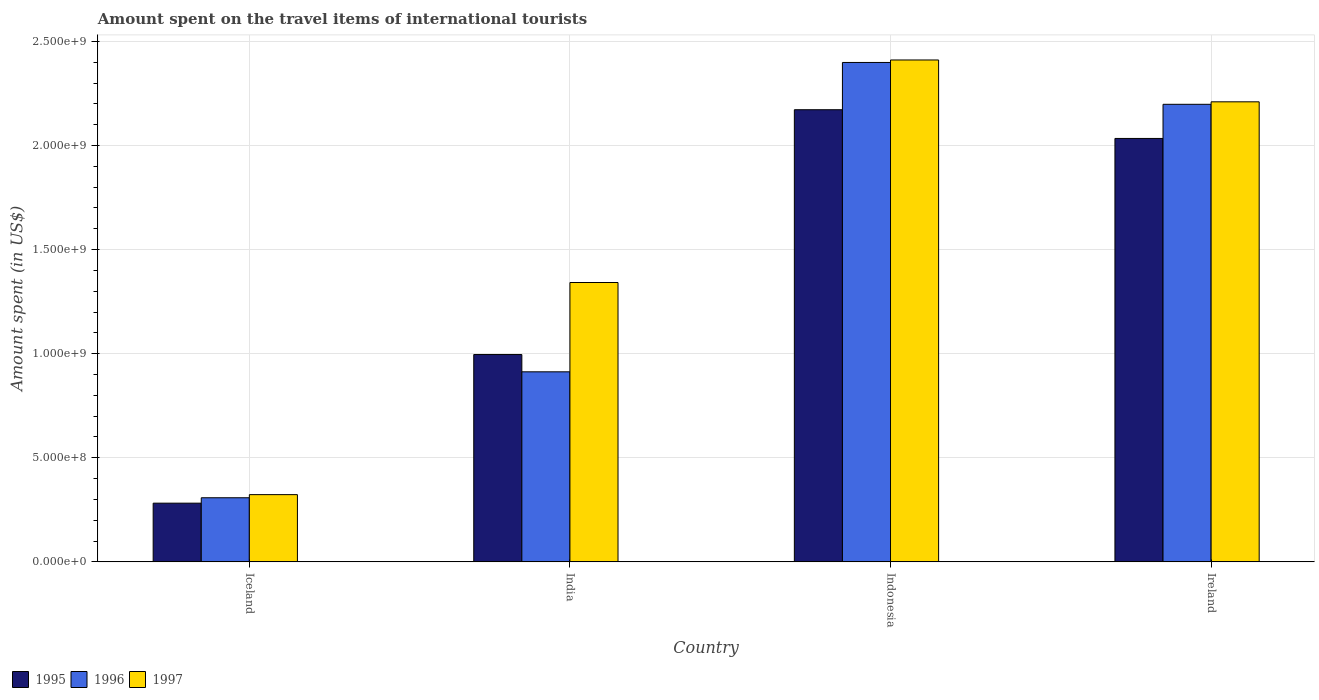How many different coloured bars are there?
Give a very brief answer. 3. How many groups of bars are there?
Your answer should be compact. 4. Are the number of bars per tick equal to the number of legend labels?
Make the answer very short. Yes. Are the number of bars on each tick of the X-axis equal?
Your answer should be compact. Yes. How many bars are there on the 1st tick from the right?
Keep it short and to the point. 3. What is the label of the 1st group of bars from the left?
Provide a succinct answer. Iceland. In how many cases, is the number of bars for a given country not equal to the number of legend labels?
Provide a succinct answer. 0. What is the amount spent on the travel items of international tourists in 1997 in Ireland?
Make the answer very short. 2.21e+09. Across all countries, what is the maximum amount spent on the travel items of international tourists in 1997?
Ensure brevity in your answer.  2.41e+09. Across all countries, what is the minimum amount spent on the travel items of international tourists in 1995?
Offer a very short reply. 2.82e+08. In which country was the amount spent on the travel items of international tourists in 1996 maximum?
Ensure brevity in your answer.  Indonesia. What is the total amount spent on the travel items of international tourists in 1997 in the graph?
Your answer should be compact. 6.29e+09. What is the difference between the amount spent on the travel items of international tourists in 1995 in Iceland and that in Indonesia?
Give a very brief answer. -1.89e+09. What is the difference between the amount spent on the travel items of international tourists in 1997 in India and the amount spent on the travel items of international tourists in 1996 in Ireland?
Your answer should be compact. -8.56e+08. What is the average amount spent on the travel items of international tourists in 1995 per country?
Your response must be concise. 1.37e+09. What is the difference between the amount spent on the travel items of international tourists of/in 1995 and amount spent on the travel items of international tourists of/in 1997 in Ireland?
Your answer should be compact. -1.76e+08. In how many countries, is the amount spent on the travel items of international tourists in 1997 greater than 1600000000 US$?
Provide a succinct answer. 2. What is the ratio of the amount spent on the travel items of international tourists in 1996 in Iceland to that in Indonesia?
Your answer should be very brief. 0.13. What is the difference between the highest and the second highest amount spent on the travel items of international tourists in 1995?
Your answer should be very brief. 1.18e+09. What is the difference between the highest and the lowest amount spent on the travel items of international tourists in 1997?
Offer a very short reply. 2.09e+09. In how many countries, is the amount spent on the travel items of international tourists in 1995 greater than the average amount spent on the travel items of international tourists in 1995 taken over all countries?
Ensure brevity in your answer.  2. What does the 1st bar from the left in India represents?
Your answer should be very brief. 1995. What does the 1st bar from the right in Iceland represents?
Your response must be concise. 1997. Is it the case that in every country, the sum of the amount spent on the travel items of international tourists in 1996 and amount spent on the travel items of international tourists in 1997 is greater than the amount spent on the travel items of international tourists in 1995?
Your response must be concise. Yes. How many countries are there in the graph?
Your answer should be compact. 4. Are the values on the major ticks of Y-axis written in scientific E-notation?
Your response must be concise. Yes. Where does the legend appear in the graph?
Keep it short and to the point. Bottom left. How many legend labels are there?
Give a very brief answer. 3. How are the legend labels stacked?
Provide a succinct answer. Horizontal. What is the title of the graph?
Offer a very short reply. Amount spent on the travel items of international tourists. What is the label or title of the X-axis?
Offer a terse response. Country. What is the label or title of the Y-axis?
Offer a terse response. Amount spent (in US$). What is the Amount spent (in US$) of 1995 in Iceland?
Give a very brief answer. 2.82e+08. What is the Amount spent (in US$) in 1996 in Iceland?
Ensure brevity in your answer.  3.08e+08. What is the Amount spent (in US$) of 1997 in Iceland?
Your answer should be compact. 3.23e+08. What is the Amount spent (in US$) of 1995 in India?
Provide a succinct answer. 9.96e+08. What is the Amount spent (in US$) in 1996 in India?
Give a very brief answer. 9.13e+08. What is the Amount spent (in US$) in 1997 in India?
Give a very brief answer. 1.34e+09. What is the Amount spent (in US$) of 1995 in Indonesia?
Provide a succinct answer. 2.17e+09. What is the Amount spent (in US$) in 1996 in Indonesia?
Keep it short and to the point. 2.40e+09. What is the Amount spent (in US$) in 1997 in Indonesia?
Provide a succinct answer. 2.41e+09. What is the Amount spent (in US$) in 1995 in Ireland?
Your answer should be compact. 2.03e+09. What is the Amount spent (in US$) of 1996 in Ireland?
Your answer should be very brief. 2.20e+09. What is the Amount spent (in US$) of 1997 in Ireland?
Your response must be concise. 2.21e+09. Across all countries, what is the maximum Amount spent (in US$) in 1995?
Ensure brevity in your answer.  2.17e+09. Across all countries, what is the maximum Amount spent (in US$) in 1996?
Offer a terse response. 2.40e+09. Across all countries, what is the maximum Amount spent (in US$) of 1997?
Offer a very short reply. 2.41e+09. Across all countries, what is the minimum Amount spent (in US$) in 1995?
Offer a very short reply. 2.82e+08. Across all countries, what is the minimum Amount spent (in US$) of 1996?
Your answer should be very brief. 3.08e+08. Across all countries, what is the minimum Amount spent (in US$) in 1997?
Give a very brief answer. 3.23e+08. What is the total Amount spent (in US$) of 1995 in the graph?
Make the answer very short. 5.48e+09. What is the total Amount spent (in US$) in 1996 in the graph?
Your answer should be compact. 5.82e+09. What is the total Amount spent (in US$) in 1997 in the graph?
Offer a very short reply. 6.29e+09. What is the difference between the Amount spent (in US$) of 1995 in Iceland and that in India?
Your answer should be compact. -7.14e+08. What is the difference between the Amount spent (in US$) in 1996 in Iceland and that in India?
Offer a very short reply. -6.05e+08. What is the difference between the Amount spent (in US$) in 1997 in Iceland and that in India?
Offer a very short reply. -1.02e+09. What is the difference between the Amount spent (in US$) of 1995 in Iceland and that in Indonesia?
Your answer should be compact. -1.89e+09. What is the difference between the Amount spent (in US$) in 1996 in Iceland and that in Indonesia?
Offer a very short reply. -2.09e+09. What is the difference between the Amount spent (in US$) of 1997 in Iceland and that in Indonesia?
Make the answer very short. -2.09e+09. What is the difference between the Amount spent (in US$) in 1995 in Iceland and that in Ireland?
Provide a short and direct response. -1.75e+09. What is the difference between the Amount spent (in US$) in 1996 in Iceland and that in Ireland?
Your response must be concise. -1.89e+09. What is the difference between the Amount spent (in US$) of 1997 in Iceland and that in Ireland?
Your answer should be compact. -1.89e+09. What is the difference between the Amount spent (in US$) of 1995 in India and that in Indonesia?
Give a very brief answer. -1.18e+09. What is the difference between the Amount spent (in US$) of 1996 in India and that in Indonesia?
Your answer should be compact. -1.49e+09. What is the difference between the Amount spent (in US$) of 1997 in India and that in Indonesia?
Provide a succinct answer. -1.07e+09. What is the difference between the Amount spent (in US$) in 1995 in India and that in Ireland?
Your response must be concise. -1.04e+09. What is the difference between the Amount spent (in US$) in 1996 in India and that in Ireland?
Provide a succinct answer. -1.28e+09. What is the difference between the Amount spent (in US$) of 1997 in India and that in Ireland?
Provide a short and direct response. -8.68e+08. What is the difference between the Amount spent (in US$) in 1995 in Indonesia and that in Ireland?
Your response must be concise. 1.38e+08. What is the difference between the Amount spent (in US$) of 1996 in Indonesia and that in Ireland?
Provide a short and direct response. 2.01e+08. What is the difference between the Amount spent (in US$) in 1997 in Indonesia and that in Ireland?
Give a very brief answer. 2.01e+08. What is the difference between the Amount spent (in US$) in 1995 in Iceland and the Amount spent (in US$) in 1996 in India?
Provide a short and direct response. -6.31e+08. What is the difference between the Amount spent (in US$) of 1995 in Iceland and the Amount spent (in US$) of 1997 in India?
Provide a succinct answer. -1.06e+09. What is the difference between the Amount spent (in US$) in 1996 in Iceland and the Amount spent (in US$) in 1997 in India?
Your answer should be very brief. -1.03e+09. What is the difference between the Amount spent (in US$) in 1995 in Iceland and the Amount spent (in US$) in 1996 in Indonesia?
Your answer should be very brief. -2.12e+09. What is the difference between the Amount spent (in US$) in 1995 in Iceland and the Amount spent (in US$) in 1997 in Indonesia?
Offer a terse response. -2.13e+09. What is the difference between the Amount spent (in US$) in 1996 in Iceland and the Amount spent (in US$) in 1997 in Indonesia?
Ensure brevity in your answer.  -2.10e+09. What is the difference between the Amount spent (in US$) of 1995 in Iceland and the Amount spent (in US$) of 1996 in Ireland?
Offer a terse response. -1.92e+09. What is the difference between the Amount spent (in US$) of 1995 in Iceland and the Amount spent (in US$) of 1997 in Ireland?
Your response must be concise. -1.93e+09. What is the difference between the Amount spent (in US$) in 1996 in Iceland and the Amount spent (in US$) in 1997 in Ireland?
Offer a terse response. -1.90e+09. What is the difference between the Amount spent (in US$) of 1995 in India and the Amount spent (in US$) of 1996 in Indonesia?
Your answer should be compact. -1.40e+09. What is the difference between the Amount spent (in US$) in 1995 in India and the Amount spent (in US$) in 1997 in Indonesia?
Ensure brevity in your answer.  -1.42e+09. What is the difference between the Amount spent (in US$) of 1996 in India and the Amount spent (in US$) of 1997 in Indonesia?
Provide a succinct answer. -1.50e+09. What is the difference between the Amount spent (in US$) of 1995 in India and the Amount spent (in US$) of 1996 in Ireland?
Keep it short and to the point. -1.20e+09. What is the difference between the Amount spent (in US$) of 1995 in India and the Amount spent (in US$) of 1997 in Ireland?
Provide a succinct answer. -1.21e+09. What is the difference between the Amount spent (in US$) of 1996 in India and the Amount spent (in US$) of 1997 in Ireland?
Provide a short and direct response. -1.30e+09. What is the difference between the Amount spent (in US$) of 1995 in Indonesia and the Amount spent (in US$) of 1996 in Ireland?
Give a very brief answer. -2.60e+07. What is the difference between the Amount spent (in US$) in 1995 in Indonesia and the Amount spent (in US$) in 1997 in Ireland?
Offer a terse response. -3.80e+07. What is the difference between the Amount spent (in US$) of 1996 in Indonesia and the Amount spent (in US$) of 1997 in Ireland?
Your answer should be compact. 1.89e+08. What is the average Amount spent (in US$) of 1995 per country?
Your answer should be compact. 1.37e+09. What is the average Amount spent (in US$) of 1996 per country?
Provide a short and direct response. 1.45e+09. What is the average Amount spent (in US$) of 1997 per country?
Your answer should be very brief. 1.57e+09. What is the difference between the Amount spent (in US$) of 1995 and Amount spent (in US$) of 1996 in Iceland?
Offer a terse response. -2.60e+07. What is the difference between the Amount spent (in US$) in 1995 and Amount spent (in US$) in 1997 in Iceland?
Provide a short and direct response. -4.10e+07. What is the difference between the Amount spent (in US$) in 1996 and Amount spent (in US$) in 1997 in Iceland?
Ensure brevity in your answer.  -1.50e+07. What is the difference between the Amount spent (in US$) in 1995 and Amount spent (in US$) in 1996 in India?
Offer a terse response. 8.30e+07. What is the difference between the Amount spent (in US$) in 1995 and Amount spent (in US$) in 1997 in India?
Ensure brevity in your answer.  -3.46e+08. What is the difference between the Amount spent (in US$) of 1996 and Amount spent (in US$) of 1997 in India?
Your answer should be compact. -4.29e+08. What is the difference between the Amount spent (in US$) in 1995 and Amount spent (in US$) in 1996 in Indonesia?
Your answer should be very brief. -2.27e+08. What is the difference between the Amount spent (in US$) of 1995 and Amount spent (in US$) of 1997 in Indonesia?
Your response must be concise. -2.39e+08. What is the difference between the Amount spent (in US$) of 1996 and Amount spent (in US$) of 1997 in Indonesia?
Give a very brief answer. -1.20e+07. What is the difference between the Amount spent (in US$) of 1995 and Amount spent (in US$) of 1996 in Ireland?
Provide a short and direct response. -1.64e+08. What is the difference between the Amount spent (in US$) of 1995 and Amount spent (in US$) of 1997 in Ireland?
Keep it short and to the point. -1.76e+08. What is the difference between the Amount spent (in US$) of 1996 and Amount spent (in US$) of 1997 in Ireland?
Ensure brevity in your answer.  -1.20e+07. What is the ratio of the Amount spent (in US$) of 1995 in Iceland to that in India?
Your response must be concise. 0.28. What is the ratio of the Amount spent (in US$) of 1996 in Iceland to that in India?
Offer a terse response. 0.34. What is the ratio of the Amount spent (in US$) in 1997 in Iceland to that in India?
Make the answer very short. 0.24. What is the ratio of the Amount spent (in US$) in 1995 in Iceland to that in Indonesia?
Ensure brevity in your answer.  0.13. What is the ratio of the Amount spent (in US$) in 1996 in Iceland to that in Indonesia?
Provide a succinct answer. 0.13. What is the ratio of the Amount spent (in US$) of 1997 in Iceland to that in Indonesia?
Give a very brief answer. 0.13. What is the ratio of the Amount spent (in US$) in 1995 in Iceland to that in Ireland?
Your response must be concise. 0.14. What is the ratio of the Amount spent (in US$) of 1996 in Iceland to that in Ireland?
Ensure brevity in your answer.  0.14. What is the ratio of the Amount spent (in US$) in 1997 in Iceland to that in Ireland?
Keep it short and to the point. 0.15. What is the ratio of the Amount spent (in US$) of 1995 in India to that in Indonesia?
Offer a terse response. 0.46. What is the ratio of the Amount spent (in US$) in 1996 in India to that in Indonesia?
Provide a short and direct response. 0.38. What is the ratio of the Amount spent (in US$) of 1997 in India to that in Indonesia?
Provide a succinct answer. 0.56. What is the ratio of the Amount spent (in US$) in 1995 in India to that in Ireland?
Your response must be concise. 0.49. What is the ratio of the Amount spent (in US$) in 1996 in India to that in Ireland?
Ensure brevity in your answer.  0.42. What is the ratio of the Amount spent (in US$) of 1997 in India to that in Ireland?
Your answer should be compact. 0.61. What is the ratio of the Amount spent (in US$) in 1995 in Indonesia to that in Ireland?
Give a very brief answer. 1.07. What is the ratio of the Amount spent (in US$) of 1996 in Indonesia to that in Ireland?
Make the answer very short. 1.09. What is the ratio of the Amount spent (in US$) in 1997 in Indonesia to that in Ireland?
Give a very brief answer. 1.09. What is the difference between the highest and the second highest Amount spent (in US$) of 1995?
Your response must be concise. 1.38e+08. What is the difference between the highest and the second highest Amount spent (in US$) of 1996?
Ensure brevity in your answer.  2.01e+08. What is the difference between the highest and the second highest Amount spent (in US$) in 1997?
Keep it short and to the point. 2.01e+08. What is the difference between the highest and the lowest Amount spent (in US$) in 1995?
Your answer should be very brief. 1.89e+09. What is the difference between the highest and the lowest Amount spent (in US$) of 1996?
Provide a succinct answer. 2.09e+09. What is the difference between the highest and the lowest Amount spent (in US$) in 1997?
Provide a succinct answer. 2.09e+09. 